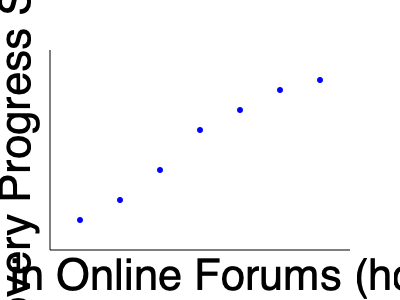Based on the scatter plot showing the relationship between time spent in online support forums and recovery progress for individuals in recovery, what type of correlation is observed, and what does this suggest about the potential impact of online forum participation on recovery outcomes? To answer this question, we need to analyze the scatter plot and understand the concepts of correlation:

1. Observe the pattern: The data points show a clear trend from the bottom-left to the top-right of the graph.

2. Identify the correlation type:
   - Positive correlation: As one variable increases, the other tends to increase.
   - Negative correlation: As one variable increases, the other tends to decrease.
   - No correlation: No clear pattern between the variables.

3. Analyze the scatter plot:
   - X-axis represents time spent in online forums (hours/week).
   - Y-axis represents recovery progress score.
   - As we move from left to right (increasing forum time), the points tend to move upward (increasing recovery progress).

4. Conclude the correlation type: This pattern indicates a positive correlation between time spent in online forums and recovery progress.

5. Interpret the results:
   - A positive correlation suggests that increased participation in online support forums is associated with higher recovery progress scores.
   - This doesn't necessarily imply causation, but it suggests a potential beneficial relationship between forum participation and recovery outcomes.

6. Consider limitations:
   - Other factors may influence recovery progress.
   - The strength of the correlation (how closely the points follow a straight line) should be considered for a more comprehensive analysis.

Given this analysis, we can conclude that the scatter plot shows a positive correlation, suggesting that increased participation in online support forums may be associated with improved recovery outcomes for individuals in recovery.
Answer: Positive correlation; suggests potential benefits of online forum participation for recovery outcomes. 